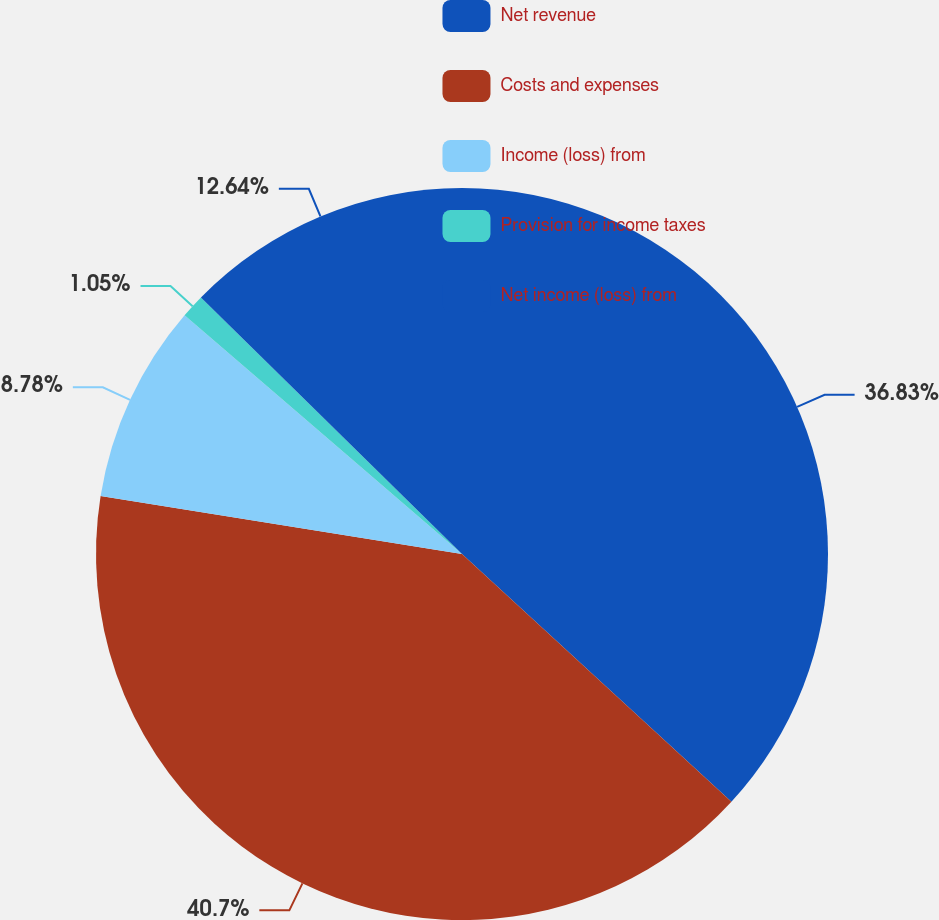Convert chart to OTSL. <chart><loc_0><loc_0><loc_500><loc_500><pie_chart><fcel>Net revenue<fcel>Costs and expenses<fcel>Income (loss) from<fcel>Provision for income taxes<fcel>Net income (loss) from<nl><fcel>36.83%<fcel>40.69%<fcel>8.78%<fcel>1.05%<fcel>12.64%<nl></chart> 